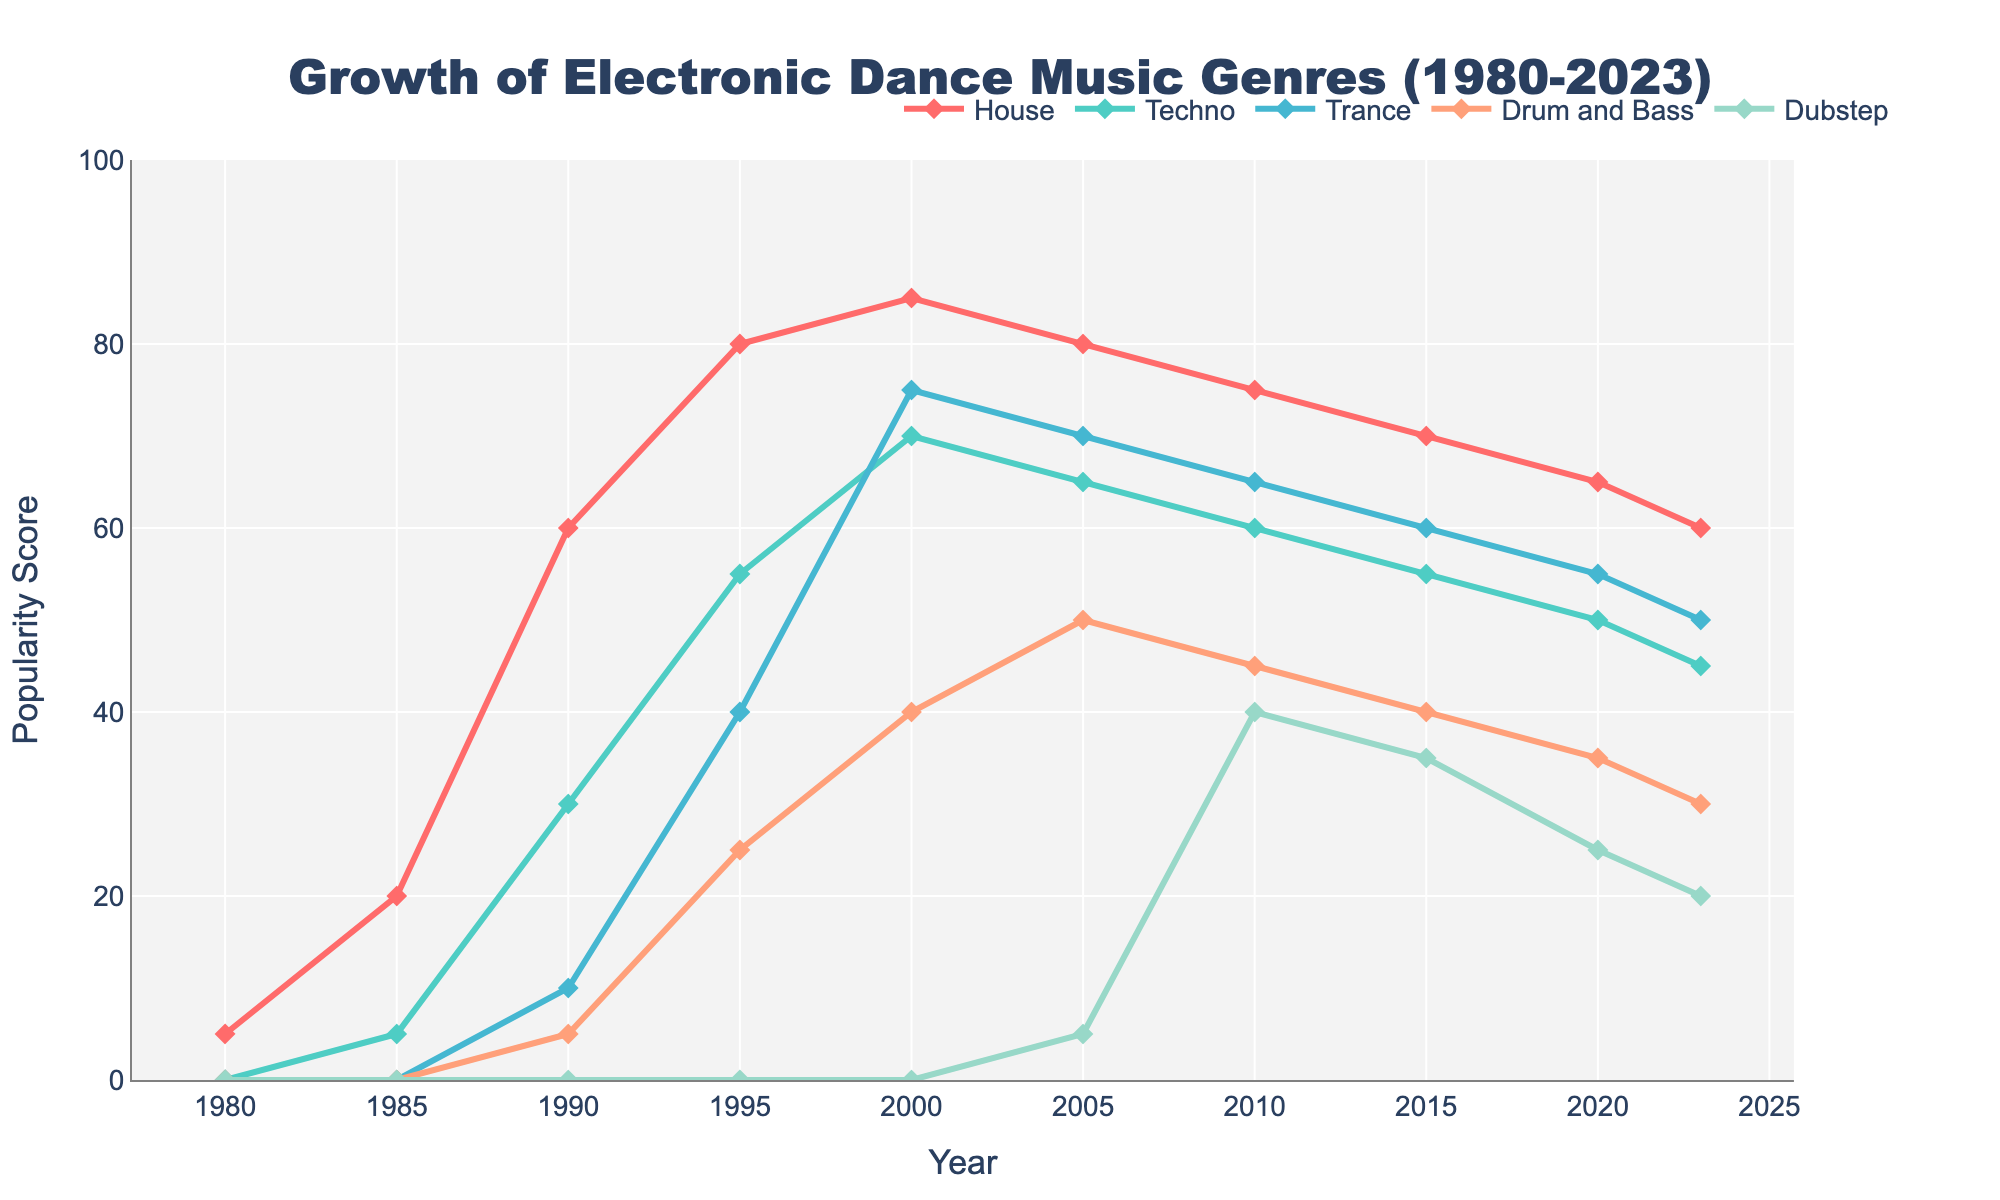How did the popularity of House music change from 1980 to 2023? The popularity of House music increased from 5 in 1980 to its peak of 85 in 2000 and then gradually declined to 60 in 2023.
Answer: It increased and then decreased Which genre saw the biggest rise in popularity between 1995 and 2000? House, Techno, Trance, and Drum and Bass all increased during this period, but Trance saw the biggest rise from 40 to 75, a gain of 35 points.
Answer: Trance Compare the popularity of Drum and Bass and Dubstep in 2010. Which one was more popular? In 2010, Drum and Bass had a popularity score of 45, while Dubstep had a score of 40. Drum and Bass was more popular.
Answer: Drum and Bass Between which years did Trance experience its greatest increase in popularity? Trance experienced its greatest increase between 1995 (40) and 2000 (75), rising by 35 points.
Answer: 1995 to 2000 What is the average popularity score of House music across all the years provided? Summing the popularity scores of House music: 5 + 20 + 60 + 80 + 85 + 80 + 75 + 70 + 65 + 60 = 600. Dividing by the number of years (10) gives an average of 60.
Answer: 60 Which genre had the second highest popularity score in 2005? In 2005, Techno had the second highest popularity score of 65, after House which had 80.
Answer: Techno How did the popularity of Dubstep evolve from its inception till 2023? Dubstep started at 0 in 1980 and 1985 and increased slowly until 2005 when it appeared with a score of 5. It then peaked at 40 in 2010 and gradually declined to 20 in 2023.
Answer: Increased then decreased In which year did Techno's popularity reach its peak? Techno's popularity reached its peak in 2000 with a score of 70.
Answer: 2000 Compare the popularity trend of House and Techno from 1980 to 2023. House music peaked in 2000, then decreased steadily, whereas Techno peaked in 2000, and also followed a declining trend post-2000. Both experienced a fall in popularity after their peaks.
Answer: Both decreased after 2000 